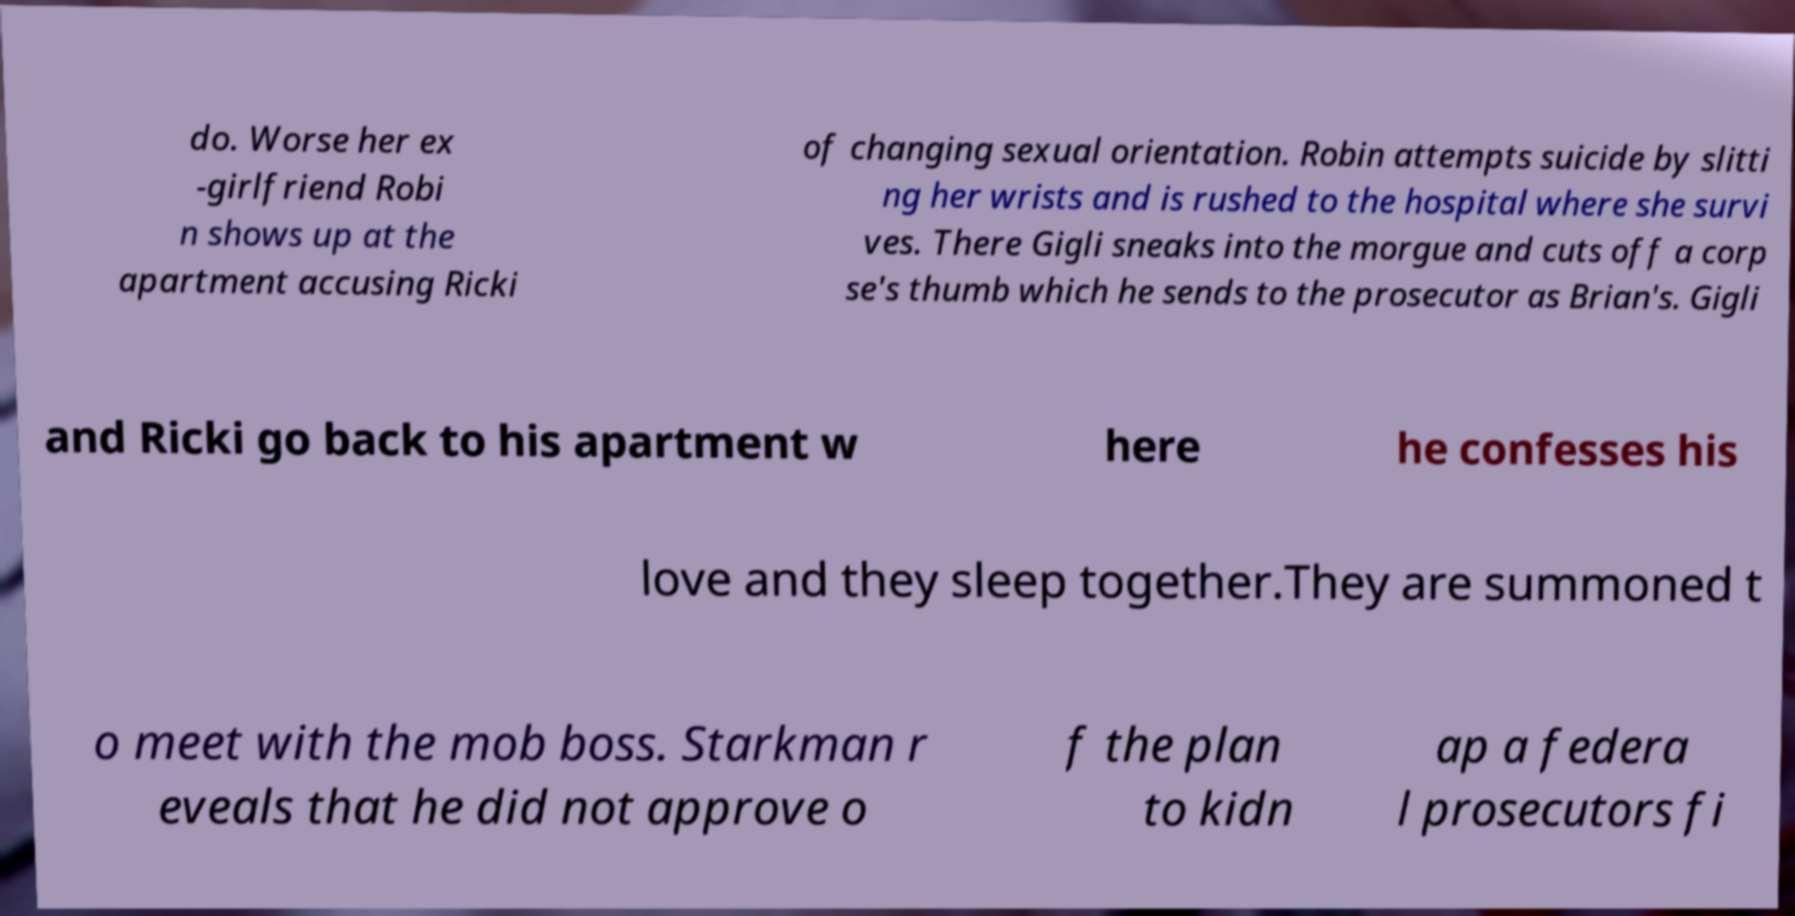Please read and relay the text visible in this image. What does it say? do. Worse her ex -girlfriend Robi n shows up at the apartment accusing Ricki of changing sexual orientation. Robin attempts suicide by slitti ng her wrists and is rushed to the hospital where she survi ves. There Gigli sneaks into the morgue and cuts off a corp se's thumb which he sends to the prosecutor as Brian's. Gigli and Ricki go back to his apartment w here he confesses his love and they sleep together.They are summoned t o meet with the mob boss. Starkman r eveals that he did not approve o f the plan to kidn ap a federa l prosecutors fi 